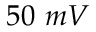<formula> <loc_0><loc_0><loc_500><loc_500>5 0 \ m V</formula> 